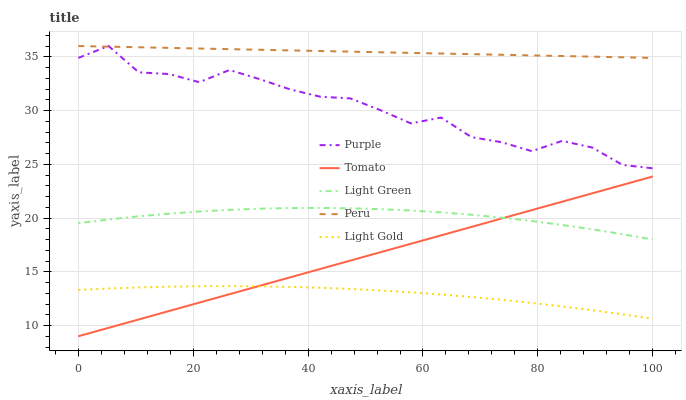Does Light Gold have the minimum area under the curve?
Answer yes or no. Yes. Does Peru have the maximum area under the curve?
Answer yes or no. Yes. Does Tomato have the minimum area under the curve?
Answer yes or no. No. Does Tomato have the maximum area under the curve?
Answer yes or no. No. Is Peru the smoothest?
Answer yes or no. Yes. Is Purple the roughest?
Answer yes or no. Yes. Is Tomato the smoothest?
Answer yes or no. No. Is Tomato the roughest?
Answer yes or no. No. Does Tomato have the lowest value?
Answer yes or no. Yes. Does Light Gold have the lowest value?
Answer yes or no. No. Does Peru have the highest value?
Answer yes or no. Yes. Does Tomato have the highest value?
Answer yes or no. No. Is Light Gold less than Light Green?
Answer yes or no. Yes. Is Purple greater than Light Gold?
Answer yes or no. Yes. Does Peru intersect Purple?
Answer yes or no. Yes. Is Peru less than Purple?
Answer yes or no. No. Is Peru greater than Purple?
Answer yes or no. No. Does Light Gold intersect Light Green?
Answer yes or no. No. 